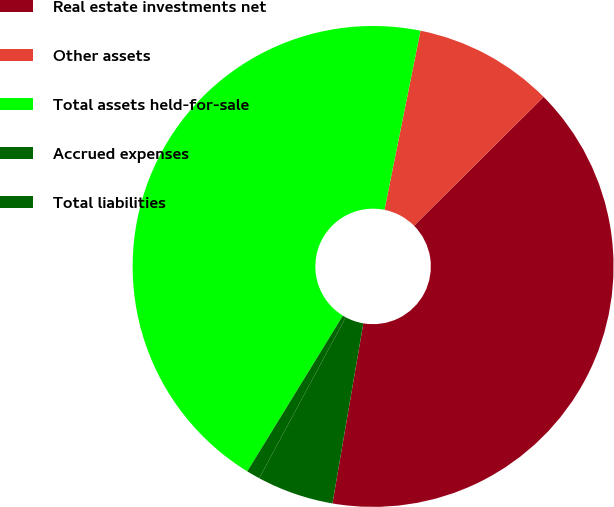Convert chart. <chart><loc_0><loc_0><loc_500><loc_500><pie_chart><fcel>Real estate investments net<fcel>Other assets<fcel>Total assets held-for-sale<fcel>Accrued expenses<fcel>Total liabilities<nl><fcel>40.16%<fcel>9.39%<fcel>44.4%<fcel>0.91%<fcel>5.15%<nl></chart> 